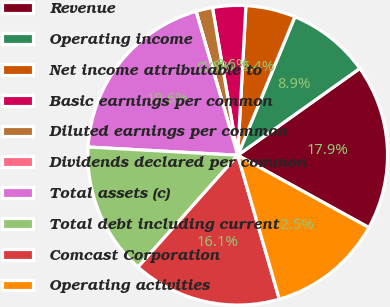Convert chart to OTSL. <chart><loc_0><loc_0><loc_500><loc_500><pie_chart><fcel>Revenue<fcel>Operating income<fcel>Net income attributable to<fcel>Basic earnings per common<fcel>Diluted earnings per common<fcel>Dividends declared per common<fcel>Total assets (c)<fcel>Total debt including current<fcel>Comcast Corporation<fcel>Operating activities<nl><fcel>17.86%<fcel>8.93%<fcel>5.36%<fcel>3.57%<fcel>1.79%<fcel>0.0%<fcel>19.64%<fcel>14.29%<fcel>16.07%<fcel>12.5%<nl></chart> 